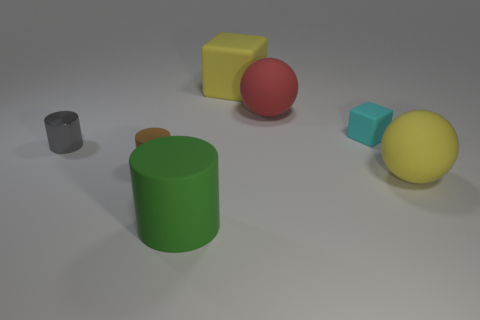Add 1 big yellow cubes. How many objects exist? 8 Subtract all blocks. How many objects are left? 5 Add 5 large blue blocks. How many large blue blocks exist? 5 Subtract 1 yellow balls. How many objects are left? 6 Subtract all gray rubber blocks. Subtract all gray metallic cylinders. How many objects are left? 6 Add 6 tiny cyan matte objects. How many tiny cyan matte objects are left? 7 